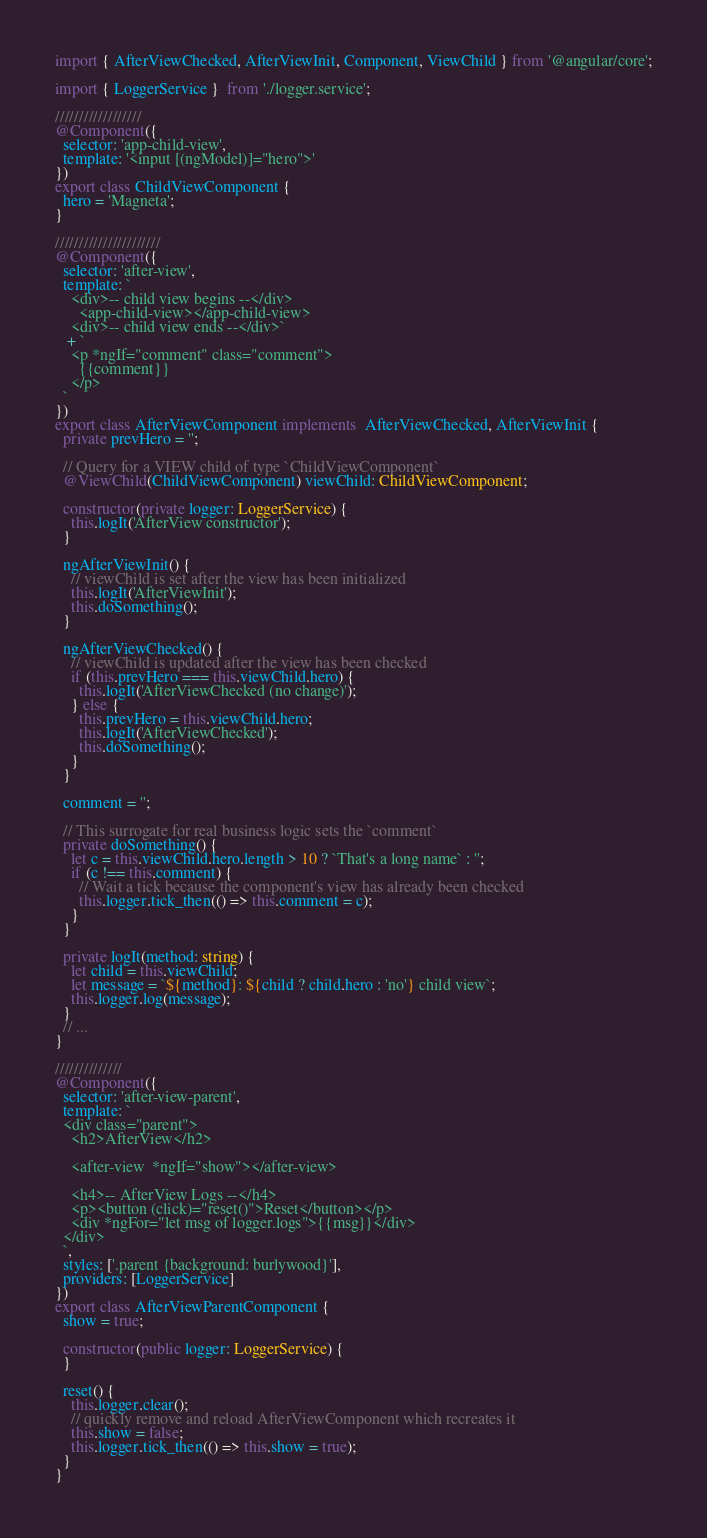Convert code to text. <code><loc_0><loc_0><loc_500><loc_500><_TypeScript_>import { AfterViewChecked, AfterViewInit, Component, ViewChild } from '@angular/core';

import { LoggerService }  from './logger.service';

//////////////////
@Component({
  selector: 'app-child-view',
  template: '<input [(ngModel)]="hero">'
})
export class ChildViewComponent {
  hero = 'Magneta';
}

//////////////////////
@Component({
  selector: 'after-view',
  template: `
    <div>-- child view begins --</div>
      <app-child-view></app-child-view>
    <div>-- child view ends --</div>`
   + `
    <p *ngIf="comment" class="comment">
      {{comment}}
    </p>
  `
})
export class AfterViewComponent implements  AfterViewChecked, AfterViewInit {
  private prevHero = '';

  // Query for a VIEW child of type `ChildViewComponent`
  @ViewChild(ChildViewComponent) viewChild: ChildViewComponent;

  constructor(private logger: LoggerService) {
    this.logIt('AfterView constructor');
  }

  ngAfterViewInit() {
    // viewChild is set after the view has been initialized
    this.logIt('AfterViewInit');
    this.doSomething();
  }

  ngAfterViewChecked() {
    // viewChild is updated after the view has been checked
    if (this.prevHero === this.viewChild.hero) {
      this.logIt('AfterViewChecked (no change)');
    } else {
      this.prevHero = this.viewChild.hero;
      this.logIt('AfterViewChecked');
      this.doSomething();
    }
  }

  comment = '';

  // This surrogate for real business logic sets the `comment`
  private doSomething() {
    let c = this.viewChild.hero.length > 10 ? `That's a long name` : '';
    if (c !== this.comment) {
      // Wait a tick because the component's view has already been checked
      this.logger.tick_then(() => this.comment = c);
    }
  }

  private logIt(method: string) {
    let child = this.viewChild;
    let message = `${method}: ${child ? child.hero : 'no'} child view`;
    this.logger.log(message);
  }
  // ...
}

//////////////
@Component({
  selector: 'after-view-parent',
  template: `
  <div class="parent">
    <h2>AfterView</h2>

    <after-view  *ngIf="show"></after-view>

    <h4>-- AfterView Logs --</h4>
    <p><button (click)="reset()">Reset</button></p>
    <div *ngFor="let msg of logger.logs">{{msg}}</div>
  </div>
  `,
  styles: ['.parent {background: burlywood}'],
  providers: [LoggerService]
})
export class AfterViewParentComponent {
  show = true;

  constructor(public logger: LoggerService) {
  }

  reset() {
    this.logger.clear();
    // quickly remove and reload AfterViewComponent which recreates it
    this.show = false;
    this.logger.tick_then(() => this.show = true);
  }
}
</code> 